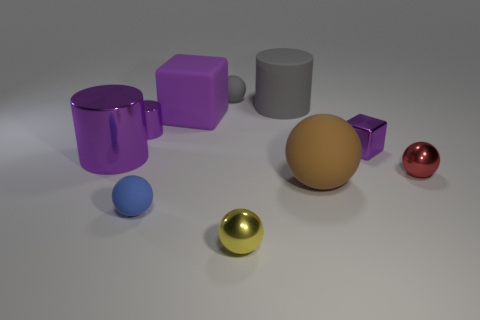There is a large thing that is the same shape as the tiny blue rubber object; what material is it?
Keep it short and to the point. Rubber. Are there fewer small rubber objects that are in front of the small cube than tiny purple cylinders?
Your answer should be very brief. No. There is a rubber object left of the large purple rubber cube; is it the same shape as the small yellow shiny thing?
Keep it short and to the point. Yes. Is there anything else that is the same color as the large sphere?
Provide a succinct answer. No. The gray sphere that is made of the same material as the small blue thing is what size?
Offer a terse response. Small. What material is the small cylinder right of the shiny cylinder that is in front of the tiny purple thing that is left of the small yellow thing?
Give a very brief answer. Metal. Are there fewer blue objects than gray objects?
Your answer should be very brief. Yes. Do the small red sphere and the small gray ball have the same material?
Your answer should be very brief. No. There is a large metallic thing that is the same color as the rubber block; what is its shape?
Your answer should be compact. Cylinder. There is a tiny rubber ball that is to the right of the tiny blue object; is its color the same as the large rubber cylinder?
Make the answer very short. Yes. 